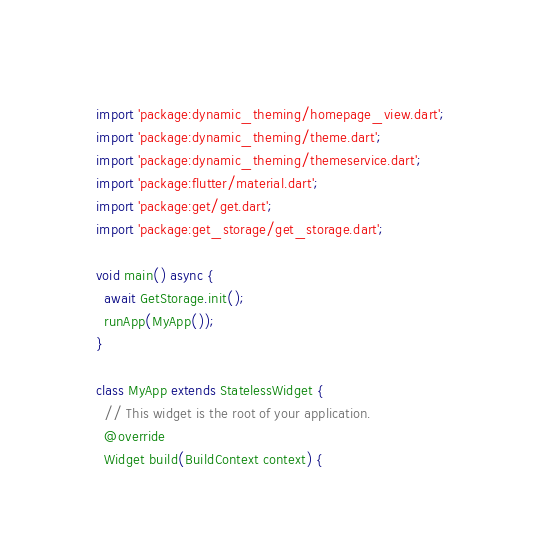Convert code to text. <code><loc_0><loc_0><loc_500><loc_500><_Dart_>import 'package:dynamic_theming/homepage_view.dart';
import 'package:dynamic_theming/theme.dart';
import 'package:dynamic_theming/themeservice.dart';
import 'package:flutter/material.dart';
import 'package:get/get.dart';
import 'package:get_storage/get_storage.dart';

void main() async {
  await GetStorage.init();
  runApp(MyApp());
}

class MyApp extends StatelessWidget {
  // This widget is the root of your application.
  @override
  Widget build(BuildContext context) {</code> 